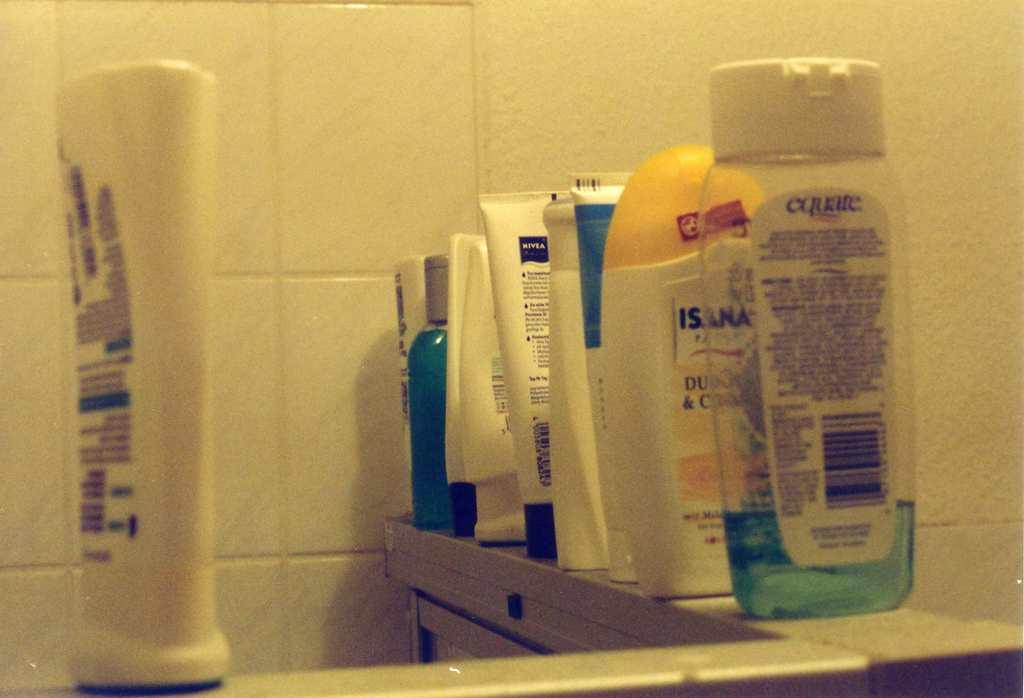<image>
Render a clear and concise summary of the photo. A bottle of equate shampoo sits with several other shampoos on a shower ledge. 